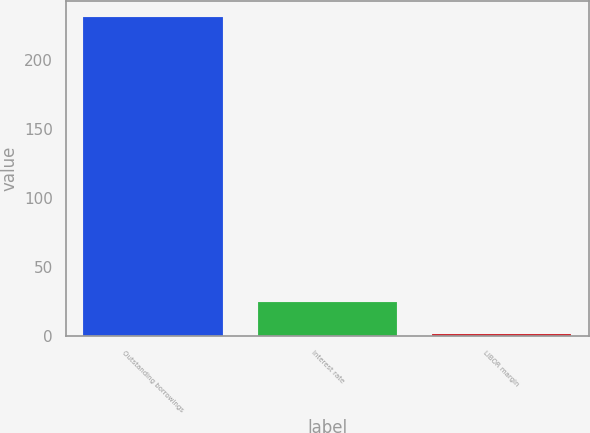Convert chart to OTSL. <chart><loc_0><loc_0><loc_500><loc_500><bar_chart><fcel>Outstanding borrowings<fcel>Interest rate<fcel>LIBOR margin<nl><fcel>231<fcel>24.45<fcel>1.5<nl></chart> 